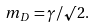Convert formula to latex. <formula><loc_0><loc_0><loc_500><loc_500>m _ { D } = \gamma / \surd 2 .</formula> 